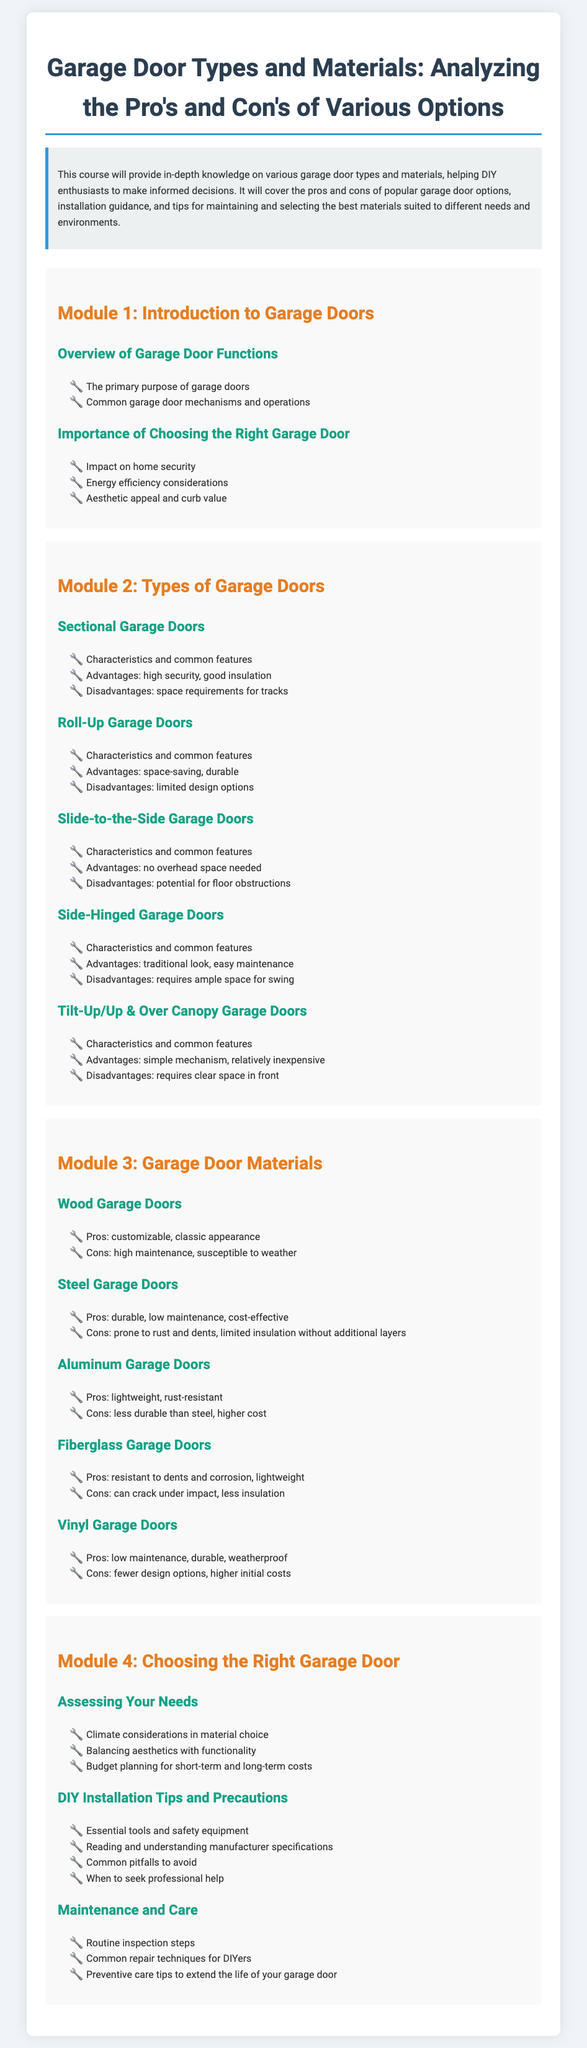What is the main focus of the syllabus? The syllabus focuses on providing in-depth knowledge on various garage door types and materials, including pros and cons, installation guidance, and maintenance tips.
Answer: Garage door types and materials How many modules are included in the syllabus? The syllabus contains four modules that cover different aspects of garage doors.
Answer: Four What are the advantages of sectional garage doors? Advantages of sectional garage doors include high security and good insulation, as stated in the document.
Answer: High security, good insulation What is a disadvantage of aluminum garage doors? According to the syllabus, a notable disadvantage of aluminum garage doors is that they are less durable than steel.
Answer: Less durable than steel What type of garage door is characterized by "no overhead space needed"? The syllabus describes slide-to-the-side garage doors as the type that requires no overhead space.
Answer: Slide-to-the-side Which module discusses DIY installation tips? DIY installation tips are covered in Module 4 of the syllabus.
Answer: Module 4 What material is known for being lightweight and rust-resistant? The document describes aluminum garage doors as known for being lightweight and rust-resistant.
Answer: Aluminum What should be considered in assessing your needs for a garage door? In assessing your needs, climate considerations, aesthetics, and budget planning should be considered.
Answer: Climate considerations What is one of the common repair techniques for DIYers mentioned? The syllabus lists common repair techniques as part of the maintenance and care module.
Answer: Common repair techniques 